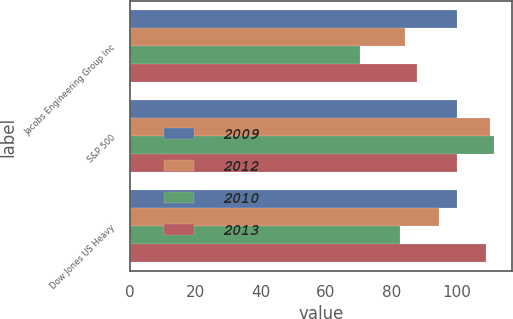Convert chart to OTSL. <chart><loc_0><loc_0><loc_500><loc_500><stacked_bar_chart><ecel><fcel>Jacobs Engineering Group Inc<fcel>S&P 500<fcel>Dow Jones US Heavy<nl><fcel>2009<fcel>100<fcel>100<fcel>100<nl><fcel>2012<fcel>84.22<fcel>110.16<fcel>94.54<nl><fcel>2010<fcel>70.27<fcel>111.42<fcel>82.7<nl><fcel>2013<fcel>87.99<fcel>100<fcel>109.07<nl></chart> 